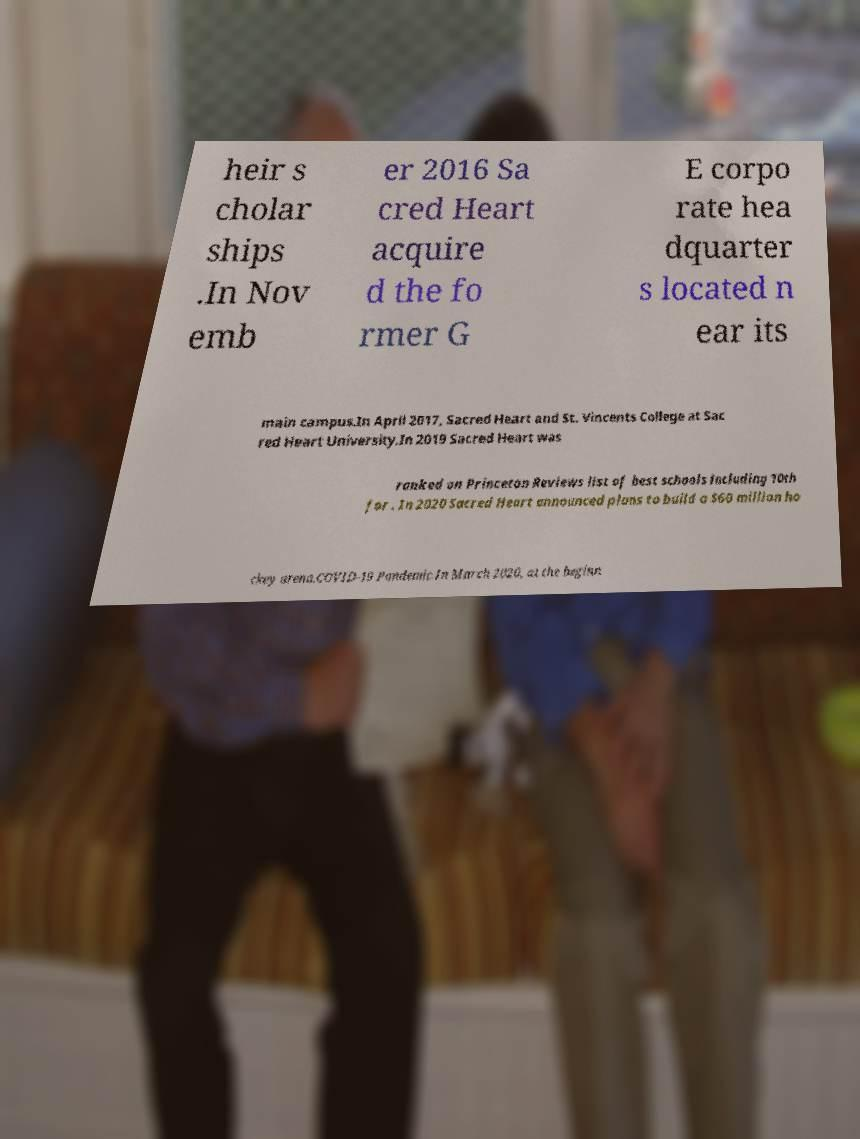Could you extract and type out the text from this image? heir s cholar ships .In Nov emb er 2016 Sa cred Heart acquire d the fo rmer G E corpo rate hea dquarter s located n ear its main campus.In April 2017, Sacred Heart and St. Vincents College at Sac red Heart University.In 2019 Sacred Heart was ranked on Princeton Reviews list of best schools including 10th for . In 2020 Sacred Heart announced plans to build a $60 million ho ckey arena.COVID-19 Pandemic.In March 2020, at the beginn 